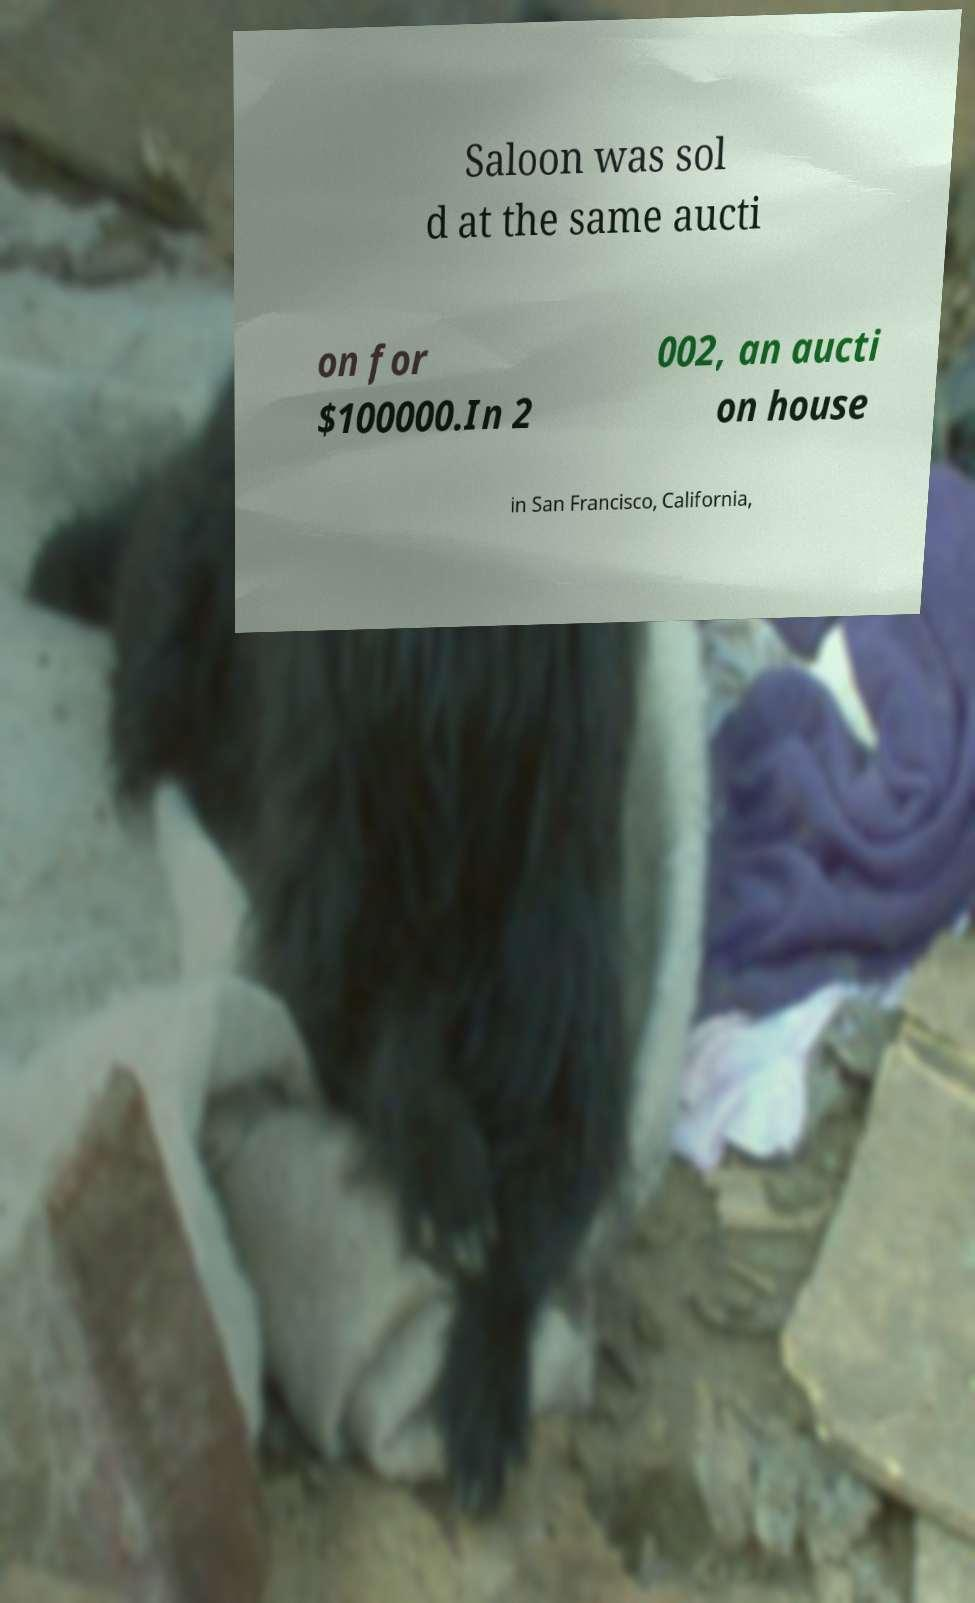I need the written content from this picture converted into text. Can you do that? Saloon was sol d at the same aucti on for $100000.In 2 002, an aucti on house in San Francisco, California, 